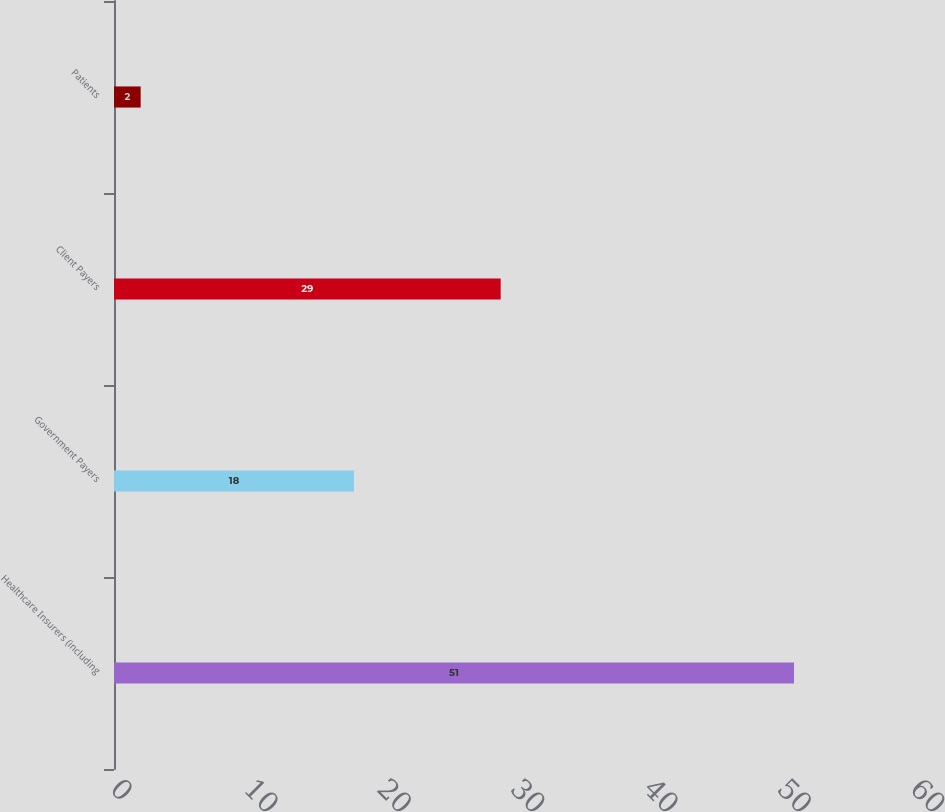<chart> <loc_0><loc_0><loc_500><loc_500><bar_chart><fcel>Healthcare Insurers (including<fcel>Government Payers<fcel>Client Payers<fcel>Patients<nl><fcel>51<fcel>18<fcel>29<fcel>2<nl></chart> 